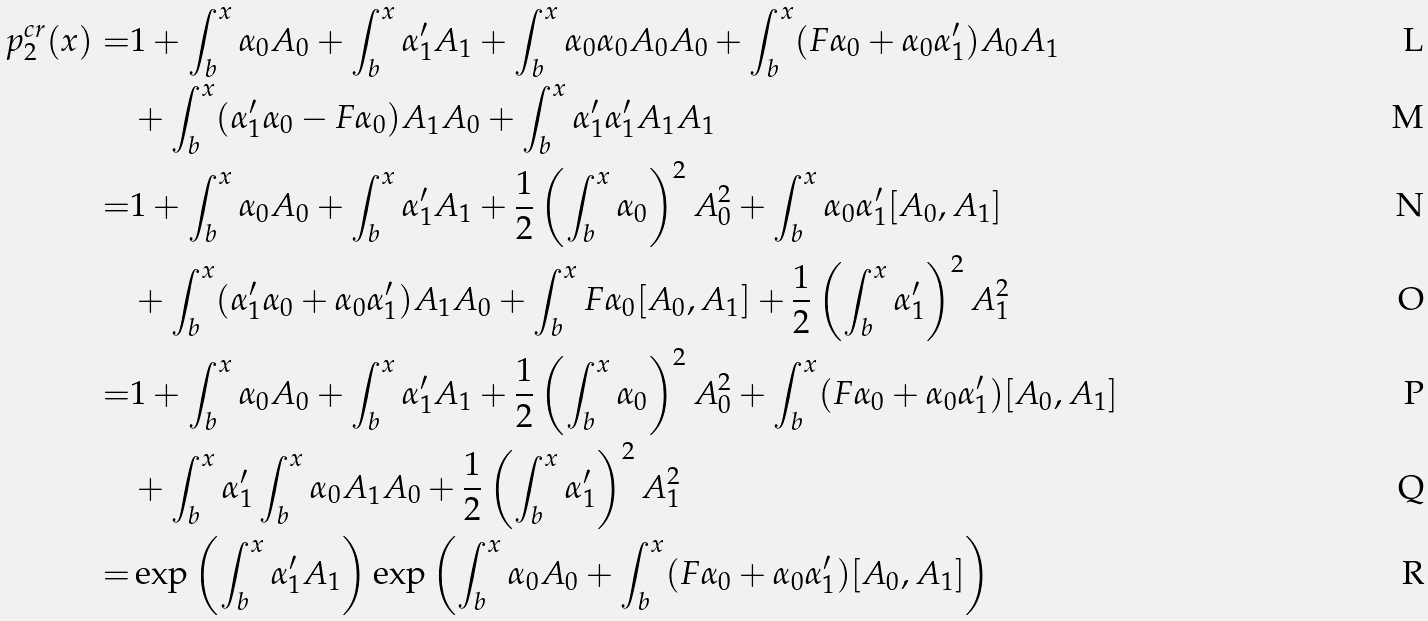Convert formula to latex. <formula><loc_0><loc_0><loc_500><loc_500>p ^ { c r } _ { 2 } ( x ) = & 1 + \int _ { b } ^ { x } \alpha _ { 0 } A _ { 0 } + \int _ { b } ^ { x } \alpha _ { 1 } ^ { \prime } A _ { 1 } + \int _ { b } ^ { x } \alpha _ { 0 } \alpha _ { 0 } A _ { 0 } A _ { 0 } + \int _ { b } ^ { x } ( F \alpha _ { 0 } + \alpha _ { 0 } \alpha _ { 1 } ^ { \prime } ) A _ { 0 } A _ { 1 } \\ & + \int _ { b } ^ { x } ( \alpha _ { 1 } ^ { \prime } \alpha _ { 0 } - F \alpha _ { 0 } ) A _ { 1 } A _ { 0 } + \int _ { b } ^ { x } \alpha _ { 1 } ^ { \prime } \alpha _ { 1 } ^ { \prime } A _ { 1 } A _ { 1 } \\ = & 1 + \int _ { b } ^ { x } \alpha _ { 0 } A _ { 0 } + \int ^ { x } _ { b } \alpha _ { 1 } ^ { \prime } A _ { 1 } + \frac { 1 } { 2 } \left ( \int _ { b } ^ { x } \alpha _ { 0 } \right ) ^ { 2 } A _ { 0 } ^ { 2 } + \int _ { b } ^ { x } \alpha _ { 0 } \alpha _ { 1 } ^ { \prime } [ A _ { 0 } , A _ { 1 } ] \\ & + \int _ { b } ^ { x } ( \alpha _ { 1 } ^ { \prime } \alpha _ { 0 } + \alpha _ { 0 } \alpha _ { 1 } ^ { \prime } ) A _ { 1 } A _ { 0 } + \int _ { b } ^ { x } F \alpha _ { 0 } [ A _ { 0 } , A _ { 1 } ] + \frac { 1 } { 2 } \left ( \int _ { b } ^ { x } \alpha _ { 1 } ^ { \prime } \right ) ^ { 2 } A _ { 1 } ^ { 2 } \\ = & 1 + \int _ { b } ^ { x } \alpha _ { 0 } A _ { 0 } + \int ^ { x } _ { b } \alpha _ { 1 } ^ { \prime } A _ { 1 } + \frac { 1 } { 2 } \left ( \int _ { b } ^ { x } \alpha _ { 0 } \right ) ^ { 2 } A _ { 0 } ^ { 2 } + \int _ { b } ^ { x } ( F \alpha _ { 0 } + \alpha _ { 0 } \alpha _ { 1 } ^ { \prime } ) [ A _ { 0 } , A _ { 1 } ] \\ & + \int _ { b } ^ { x } \alpha _ { 1 } ^ { \prime } \int _ { b } ^ { x } \alpha _ { 0 } A _ { 1 } A _ { 0 } + \frac { 1 } { 2 } \left ( \int _ { b } ^ { x } \alpha _ { 1 } ^ { \prime } \right ) ^ { 2 } A _ { 1 } ^ { 2 } \\ = & \exp \left ( \int _ { b } ^ { x } \alpha _ { 1 } ^ { \prime } A _ { 1 } \right ) \exp \left ( \int _ { b } ^ { x } \alpha _ { 0 } A _ { 0 } + \int _ { b } ^ { x } ( F \alpha _ { 0 } + \alpha _ { 0 } \alpha _ { 1 } ^ { \prime } ) [ A _ { 0 } , A _ { 1 } ] \right )</formula> 